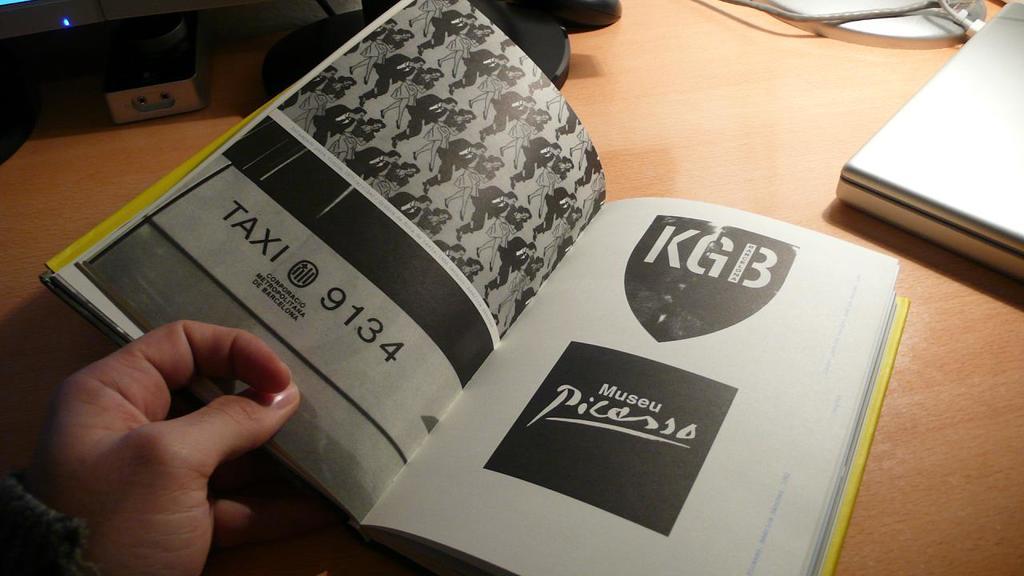What taxi number is displayed on the page on the left?
Make the answer very short. 9134. What initials are shown on the top of the right side page?
Offer a very short reply. Kgb. 